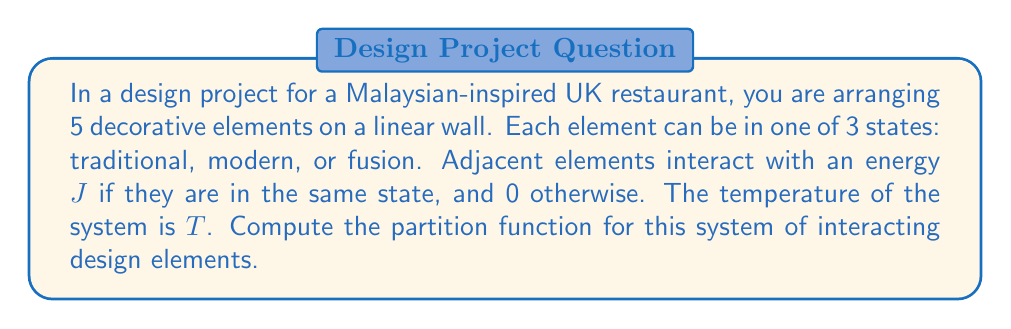What is the answer to this math problem? Let's approach this step-by-step:

1) First, we need to understand what the partition function represents. In statistical mechanics, the partition function $Z$ is given by:

   $$Z = \sum_{\text{all states}} e^{-\beta E}$$

   where $\beta = \frac{1}{k_B T}$, $k_B$ is Boltzmann's constant, $T$ is temperature, and $E$ is the energy of each state.

2) In our case, we have 5 elements, each with 3 possible states. The total number of possible configurations is $3^5 = 243$.

3) The energy of a configuration depends on the number of adjacent elements in the same state. Let's call this number $n$. The energy of a configuration is then $E = -nJ$.

4) We can categorize our configurations based on the number of adjacent pairs in the same state (n):
   - n = 0: No adjacent elements in the same state
   - n = 1: One pair of adjacent elements in the same state
   - n = 2: Two pairs of adjacent elements in the same state
   - n = 3: Three pairs of adjacent elements in the same state
   - n = 4: All elements in the same state

5) Now, let's count the number of configurations for each n:
   - n = 0: 3 * 2^4 = 48 configurations
   - n = 1: 3 * 2 * 3 * 2^2 = 72 configurations
   - n = 2: 3 * 2 * 3 * 2 + 3 * 3 * 2^2 = 72 configurations
   - n = 3: 3 * 2 * 3 + 3 * 3 * 2 = 36 configurations
   - n = 4: 3 * 1 = 3 configurations

6) Now we can write our partition function:

   $$Z = 48e^0 + 72e^{\beta J} + 72e^{2\beta J} + 36e^{3\beta J} + 3e^{4\beta J}$$

7) Simplifying:

   $$Z = 48 + 72e^{\beta J} + 72e^{2\beta J} + 36e^{3\beta J} + 3e^{4\beta J}$$

This is our final partition function.
Answer: $Z = 48 + 72e^{\beta J} + 72e^{2\beta J} + 36e^{3\beta J} + 3e^{4\beta J}$ 